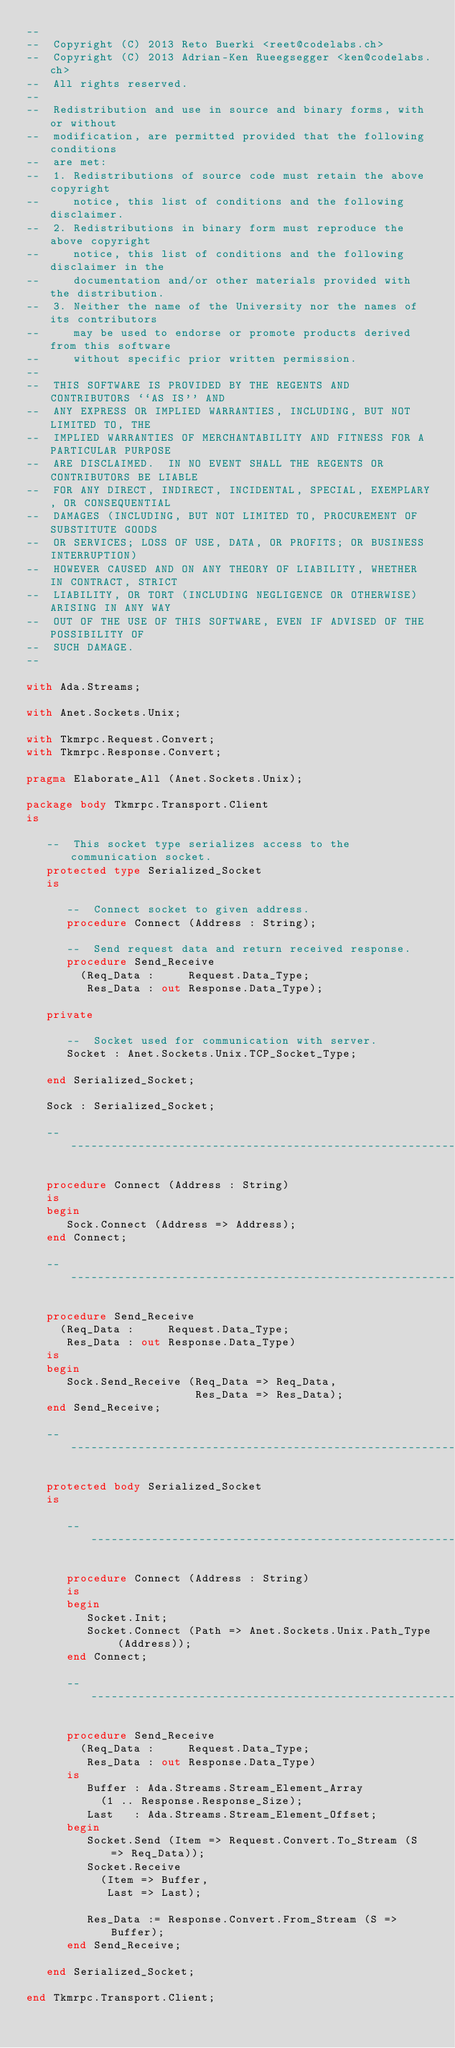Convert code to text. <code><loc_0><loc_0><loc_500><loc_500><_Ada_>--
--  Copyright (C) 2013 Reto Buerki <reet@codelabs.ch>
--  Copyright (C) 2013 Adrian-Ken Rueegsegger <ken@codelabs.ch>
--  All rights reserved.
--
--  Redistribution and use in source and binary forms, with or without
--  modification, are permitted provided that the following conditions
--  are met:
--  1. Redistributions of source code must retain the above copyright
--     notice, this list of conditions and the following disclaimer.
--  2. Redistributions in binary form must reproduce the above copyright
--     notice, this list of conditions and the following disclaimer in the
--     documentation and/or other materials provided with the distribution.
--  3. Neither the name of the University nor the names of its contributors
--     may be used to endorse or promote products derived from this software
--     without specific prior written permission.
--
--  THIS SOFTWARE IS PROVIDED BY THE REGENTS AND CONTRIBUTORS ``AS IS'' AND
--  ANY EXPRESS OR IMPLIED WARRANTIES, INCLUDING, BUT NOT LIMITED TO, THE
--  IMPLIED WARRANTIES OF MERCHANTABILITY AND FITNESS FOR A PARTICULAR PURPOSE
--  ARE DISCLAIMED.  IN NO EVENT SHALL THE REGENTS OR CONTRIBUTORS BE LIABLE
--  FOR ANY DIRECT, INDIRECT, INCIDENTAL, SPECIAL, EXEMPLARY, OR CONSEQUENTIAL
--  DAMAGES (INCLUDING, BUT NOT LIMITED TO, PROCUREMENT OF SUBSTITUTE GOODS
--  OR SERVICES; LOSS OF USE, DATA, OR PROFITS; OR BUSINESS INTERRUPTION)
--  HOWEVER CAUSED AND ON ANY THEORY OF LIABILITY, WHETHER IN CONTRACT, STRICT
--  LIABILITY, OR TORT (INCLUDING NEGLIGENCE OR OTHERWISE) ARISING IN ANY WAY
--  OUT OF THE USE OF THIS SOFTWARE, EVEN IF ADVISED OF THE POSSIBILITY OF
--  SUCH DAMAGE.
--

with Ada.Streams;

with Anet.Sockets.Unix;

with Tkmrpc.Request.Convert;
with Tkmrpc.Response.Convert;

pragma Elaborate_All (Anet.Sockets.Unix);

package body Tkmrpc.Transport.Client
is

   --  This socket type serializes access to the communication socket.
   protected type Serialized_Socket
   is

      --  Connect socket to given address.
      procedure Connect (Address : String);

      --  Send request data and return received response.
      procedure Send_Receive
        (Req_Data :     Request.Data_Type;
         Res_Data : out Response.Data_Type);

   private

      --  Socket used for communication with server.
      Socket : Anet.Sockets.Unix.TCP_Socket_Type;

   end Serialized_Socket;

   Sock : Serialized_Socket;

   -------------------------------------------------------------------------

   procedure Connect (Address : String)
   is
   begin
      Sock.Connect (Address => Address);
   end Connect;

   -------------------------------------------------------------------------

   procedure Send_Receive
     (Req_Data :     Request.Data_Type;
      Res_Data : out Response.Data_Type)
   is
   begin
      Sock.Send_Receive (Req_Data => Req_Data,
                         Res_Data => Res_Data);
   end Send_Receive;

   -------------------------------------------------------------------------

   protected body Serialized_Socket
   is

      ----------------------------------------------------------------------

      procedure Connect (Address : String)
      is
      begin
         Socket.Init;
         Socket.Connect (Path => Anet.Sockets.Unix.Path_Type (Address));
      end Connect;

      ----------------------------------------------------------------------

      procedure Send_Receive
        (Req_Data :     Request.Data_Type;
         Res_Data : out Response.Data_Type)
      is
         Buffer : Ada.Streams.Stream_Element_Array
           (1 .. Response.Response_Size);
         Last   : Ada.Streams.Stream_Element_Offset;
      begin
         Socket.Send (Item => Request.Convert.To_Stream (S => Req_Data));
         Socket.Receive
           (Item => Buffer,
            Last => Last);

         Res_Data := Response.Convert.From_Stream (S => Buffer);
      end Send_Receive;

   end Serialized_Socket;

end Tkmrpc.Transport.Client;
</code> 